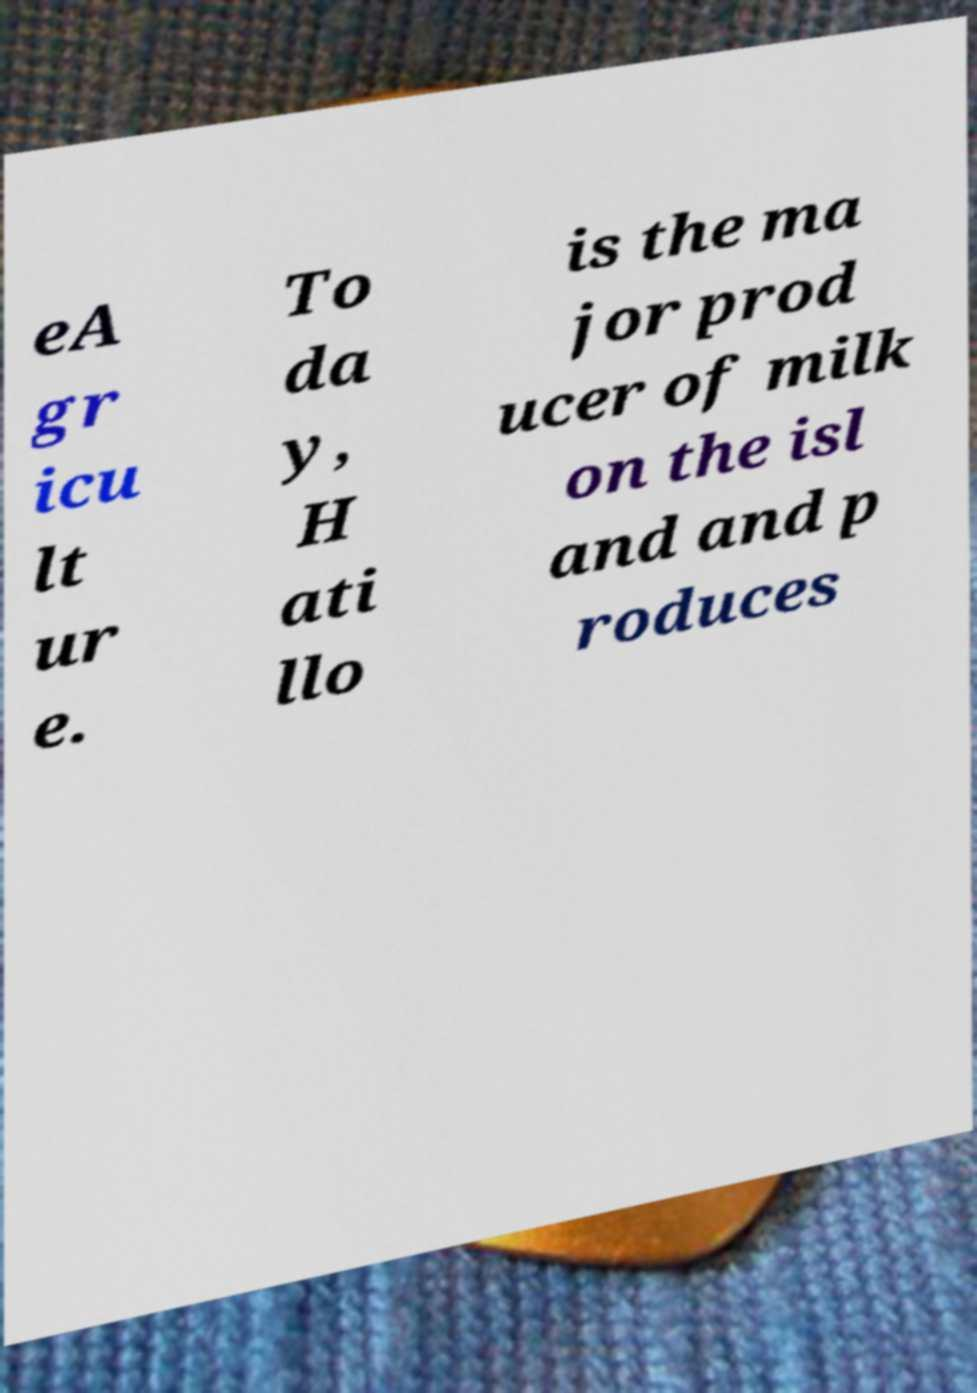What messages or text are displayed in this image? I need them in a readable, typed format. eA gr icu lt ur e. To da y, H ati llo is the ma jor prod ucer of milk on the isl and and p roduces 